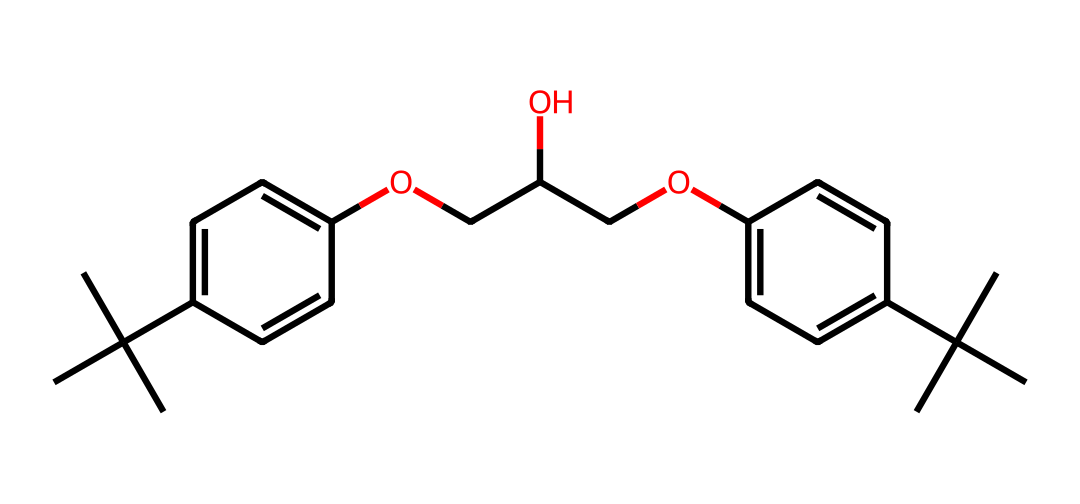What is the total number of carbon atoms in the chemical? To find the total number of carbon atoms, I will count the carbon (C) symbols in the SMILES representation. By examining the structure, I can see there are 21 carbon atoms.
Answer: 21 How many hydroxyl (–OH) groups are present in this chemical? A hydroxyl group contains an oxygen atom bonded to a hydrogen atom. By analyzing the chemical structure, I can locate two distinct oxygen atoms linked with hydrogen atoms, indicating the presence of two hydroxyl groups.
Answer: 2 What type of polymerization process likely led to the formation of this compound? The presence of multiple functional groups such as hydroxyls and alkene structures suggests that this compound may have formed through step-growth polymerization due to chain-linking of monomers with reactive sites.
Answer: step-growth What property mainly contributes to the Non-Newtonian behavior of this compound? Non-Newtonian fluids change their viscosity under stress. The presence of both flexible (polyethylene) and rigid (polystyrene) segments in the structure enables it to behave differently under varying shear rates, therefore affecting viscosity.
Answer: viscosity How many rings are present in this chemical structure? The structure contains two distinct aromatic rings, which can be identified by their cyclic arrangements and alternating bond patterns. Counting those, I find there are two rings in total.
Answer: 2 What is the significance of the ether linkages (–O–) in the structure? Ether linkages affect the solubility and flexibility of the polymer. In this case, they allow for reduced intermolecular forces, enabling the Non-Newtonian fluid properties as they improve the material's malleability and stretchability.
Answer: flexibility 